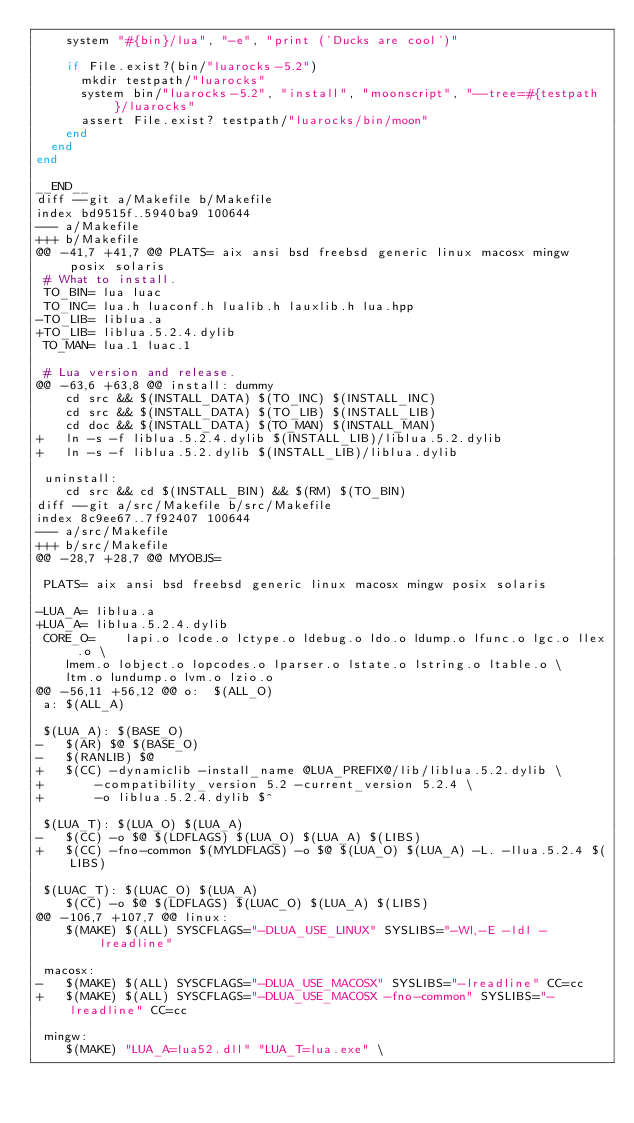Convert code to text. <code><loc_0><loc_0><loc_500><loc_500><_Ruby_>    system "#{bin}/lua", "-e", "print ('Ducks are cool')"

    if File.exist?(bin/"luarocks-5.2")
      mkdir testpath/"luarocks"
      system bin/"luarocks-5.2", "install", "moonscript", "--tree=#{testpath}/luarocks"
      assert File.exist? testpath/"luarocks/bin/moon"
    end
  end
end

__END__
diff --git a/Makefile b/Makefile
index bd9515f..5940ba9 100644
--- a/Makefile
+++ b/Makefile
@@ -41,7 +41,7 @@ PLATS= aix ansi bsd freebsd generic linux macosx mingw posix solaris
 # What to install.
 TO_BIN= lua luac
 TO_INC= lua.h luaconf.h lualib.h lauxlib.h lua.hpp
-TO_LIB= liblua.a
+TO_LIB= liblua.5.2.4.dylib
 TO_MAN= lua.1 luac.1

 # Lua version and release.
@@ -63,6 +63,8 @@ install: dummy
	cd src && $(INSTALL_DATA) $(TO_INC) $(INSTALL_INC)
	cd src && $(INSTALL_DATA) $(TO_LIB) $(INSTALL_LIB)
	cd doc && $(INSTALL_DATA) $(TO_MAN) $(INSTALL_MAN)
+	ln -s -f liblua.5.2.4.dylib $(INSTALL_LIB)/liblua.5.2.dylib
+	ln -s -f liblua.5.2.dylib $(INSTALL_LIB)/liblua.dylib

 uninstall:
	cd src && cd $(INSTALL_BIN) && $(RM) $(TO_BIN)
diff --git a/src/Makefile b/src/Makefile
index 8c9ee67..7f92407 100644
--- a/src/Makefile
+++ b/src/Makefile
@@ -28,7 +28,7 @@ MYOBJS=

 PLATS= aix ansi bsd freebsd generic linux macosx mingw posix solaris

-LUA_A=	liblua.a
+LUA_A=	liblua.5.2.4.dylib
 CORE_O=	lapi.o lcode.o lctype.o ldebug.o ldo.o ldump.o lfunc.o lgc.o llex.o \
	lmem.o lobject.o lopcodes.o lparser.o lstate.o lstring.o ltable.o \
	ltm.o lundump.o lvm.o lzio.o
@@ -56,11 +56,12 @@ o:	$(ALL_O)
 a:	$(ALL_A)

 $(LUA_A): $(BASE_O)
-	$(AR) $@ $(BASE_O)
-	$(RANLIB) $@
+	$(CC) -dynamiclib -install_name @LUA_PREFIX@/lib/liblua.5.2.dylib \
+		-compatibility_version 5.2 -current_version 5.2.4 \
+		-o liblua.5.2.4.dylib $^

 $(LUA_T): $(LUA_O) $(LUA_A)
-	$(CC) -o $@ $(LDFLAGS) $(LUA_O) $(LUA_A) $(LIBS)
+	$(CC) -fno-common $(MYLDFLAGS) -o $@ $(LUA_O) $(LUA_A) -L. -llua.5.2.4 $(LIBS)

 $(LUAC_T): $(LUAC_O) $(LUA_A)
	$(CC) -o $@ $(LDFLAGS) $(LUAC_O) $(LUA_A) $(LIBS)
@@ -106,7 +107,7 @@ linux:
	$(MAKE) $(ALL) SYSCFLAGS="-DLUA_USE_LINUX" SYSLIBS="-Wl,-E -ldl -lreadline"

 macosx:
-	$(MAKE) $(ALL) SYSCFLAGS="-DLUA_USE_MACOSX" SYSLIBS="-lreadline" CC=cc
+	$(MAKE) $(ALL) SYSCFLAGS="-DLUA_USE_MACOSX -fno-common" SYSLIBS="-lreadline" CC=cc

 mingw:
	$(MAKE) "LUA_A=lua52.dll" "LUA_T=lua.exe" \
</code> 